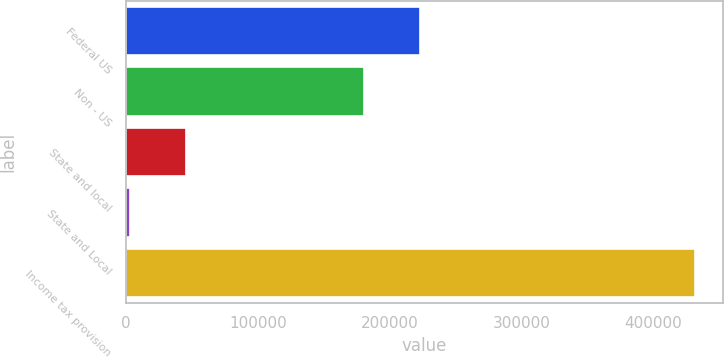Convert chart to OTSL. <chart><loc_0><loc_0><loc_500><loc_500><bar_chart><fcel>Federal US<fcel>Non - US<fcel>State and local<fcel>State and Local<fcel>Income tax provision<nl><fcel>223264<fcel>180401<fcel>45910.8<fcel>3048<fcel>431676<nl></chart> 